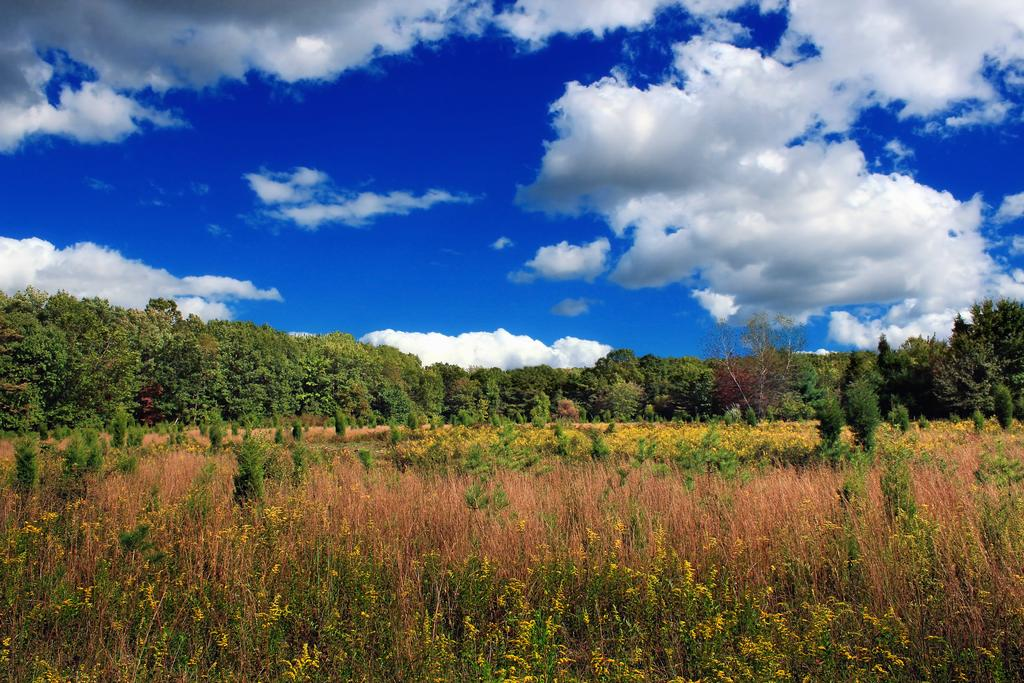What type of vegetation can be seen in the image? There are trees and plants in the image. What is visible in the sky in the image? There are clouds in the sky. How many toes can be seen on the trees in the image? Trees do not have toes, so none can be seen on them in the image. 